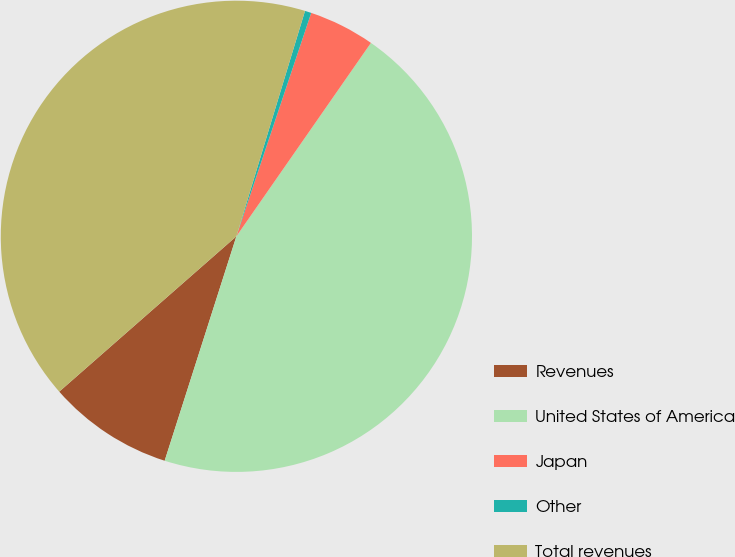Convert chart. <chart><loc_0><loc_0><loc_500><loc_500><pie_chart><fcel>Revenues<fcel>United States of America<fcel>Japan<fcel>Other<fcel>Total revenues<nl><fcel>8.62%<fcel>45.25%<fcel>4.53%<fcel>0.44%<fcel>41.16%<nl></chart> 